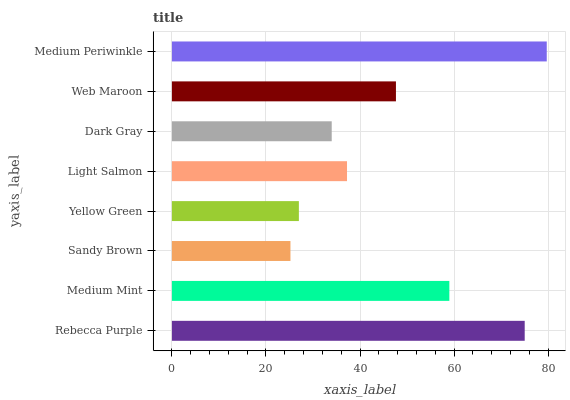Is Sandy Brown the minimum?
Answer yes or no. Yes. Is Medium Periwinkle the maximum?
Answer yes or no. Yes. Is Medium Mint the minimum?
Answer yes or no. No. Is Medium Mint the maximum?
Answer yes or no. No. Is Rebecca Purple greater than Medium Mint?
Answer yes or no. Yes. Is Medium Mint less than Rebecca Purple?
Answer yes or no. Yes. Is Medium Mint greater than Rebecca Purple?
Answer yes or no. No. Is Rebecca Purple less than Medium Mint?
Answer yes or no. No. Is Web Maroon the high median?
Answer yes or no. Yes. Is Light Salmon the low median?
Answer yes or no. Yes. Is Rebecca Purple the high median?
Answer yes or no. No. Is Medium Periwinkle the low median?
Answer yes or no. No. 